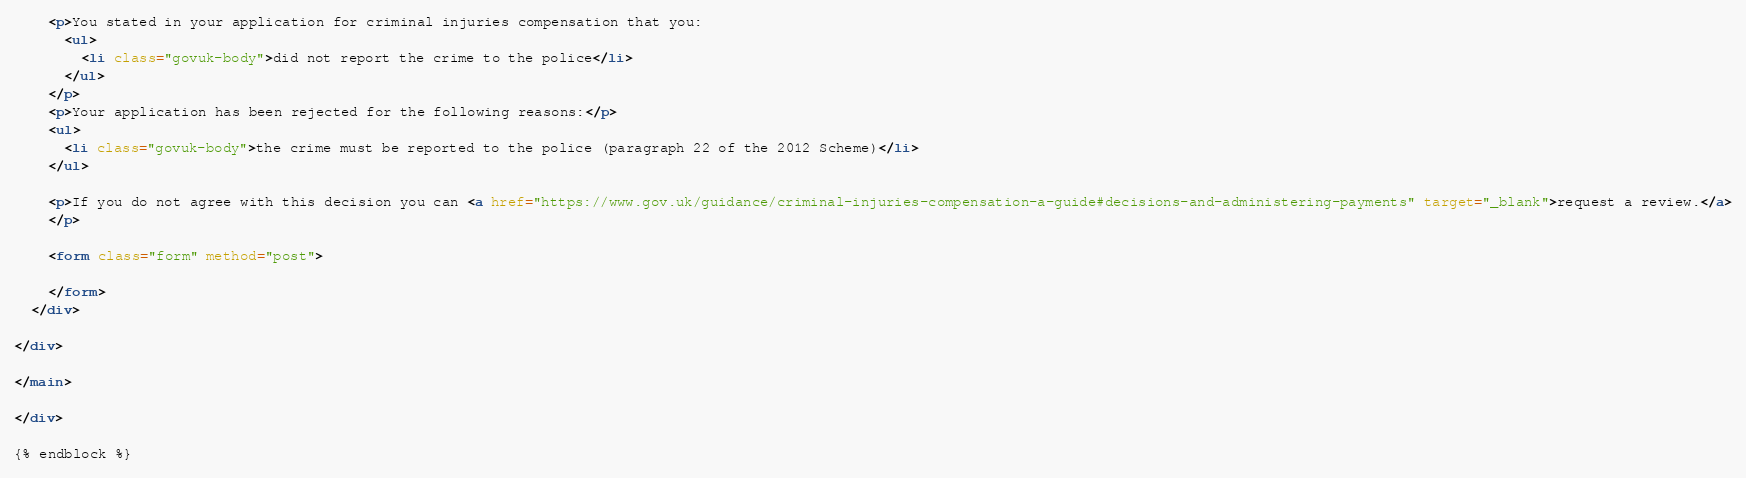<code> <loc_0><loc_0><loc_500><loc_500><_HTML_>
    <p>You stated in your application for criminal injuries compensation that you:
      <ul>
        <li class="govuk-body">did not report the crime to the police</li>
      </ul>
    </p>
    <p>Your application has been rejected for the following reasons:</p>
    <ul>
      <li class="govuk-body">the crime must be reported to the police (paragraph 22 of the 2012 Scheme)</li>
    </ul>

    <p>If you do not agree with this decision you can <a href="https://www.gov.uk/guidance/criminal-injuries-compensation-a-guide#decisions-and-administering-payments" target="_blank">request a review.</a>
    </p>

    <form class="form" method="post">

    </form>
  </div>

</div>

</main>

</div>

{% endblock %}</code> 